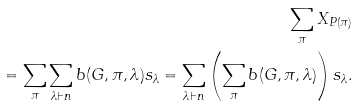<formula> <loc_0><loc_0><loc_500><loc_500>\sum _ { \pi } X _ { P ( \pi ) } \\ = \sum _ { \pi } \sum _ { \lambda \vdash n } b ( G , \pi , \lambda ) s _ { \lambda } = \sum _ { \lambda \vdash n } \left ( \sum _ { \pi } b ( G , \pi , \lambda ) \right ) s _ { \lambda } .</formula> 